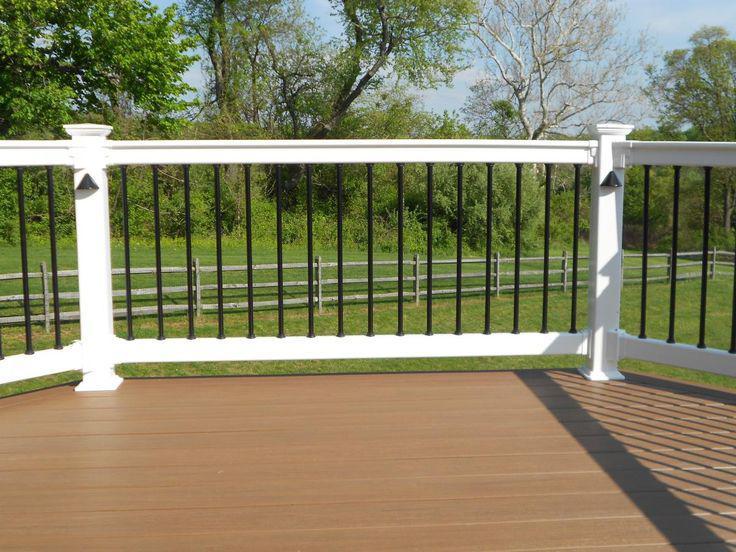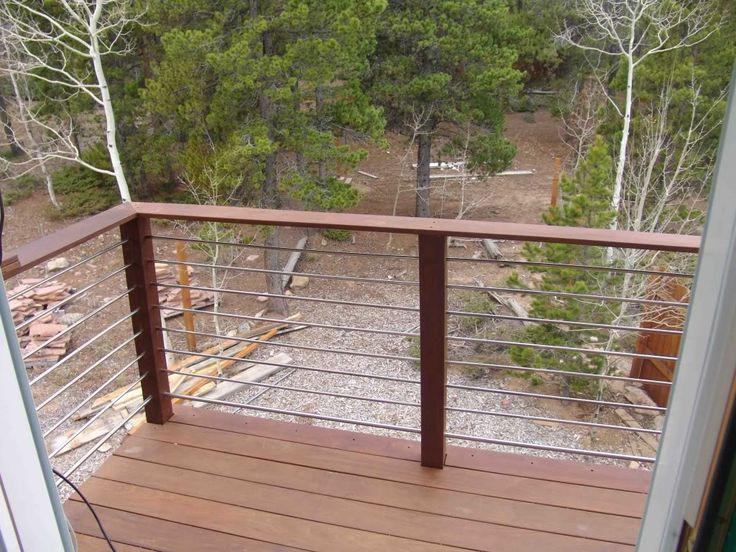The first image is the image on the left, the second image is the image on the right. For the images shown, is this caption "The right image shows a corner of a wood railed deck with vertical wooden bars that are not casting shadows, and the left image shows a horizontal section of railing with vertical bars." true? Answer yes or no. No. 